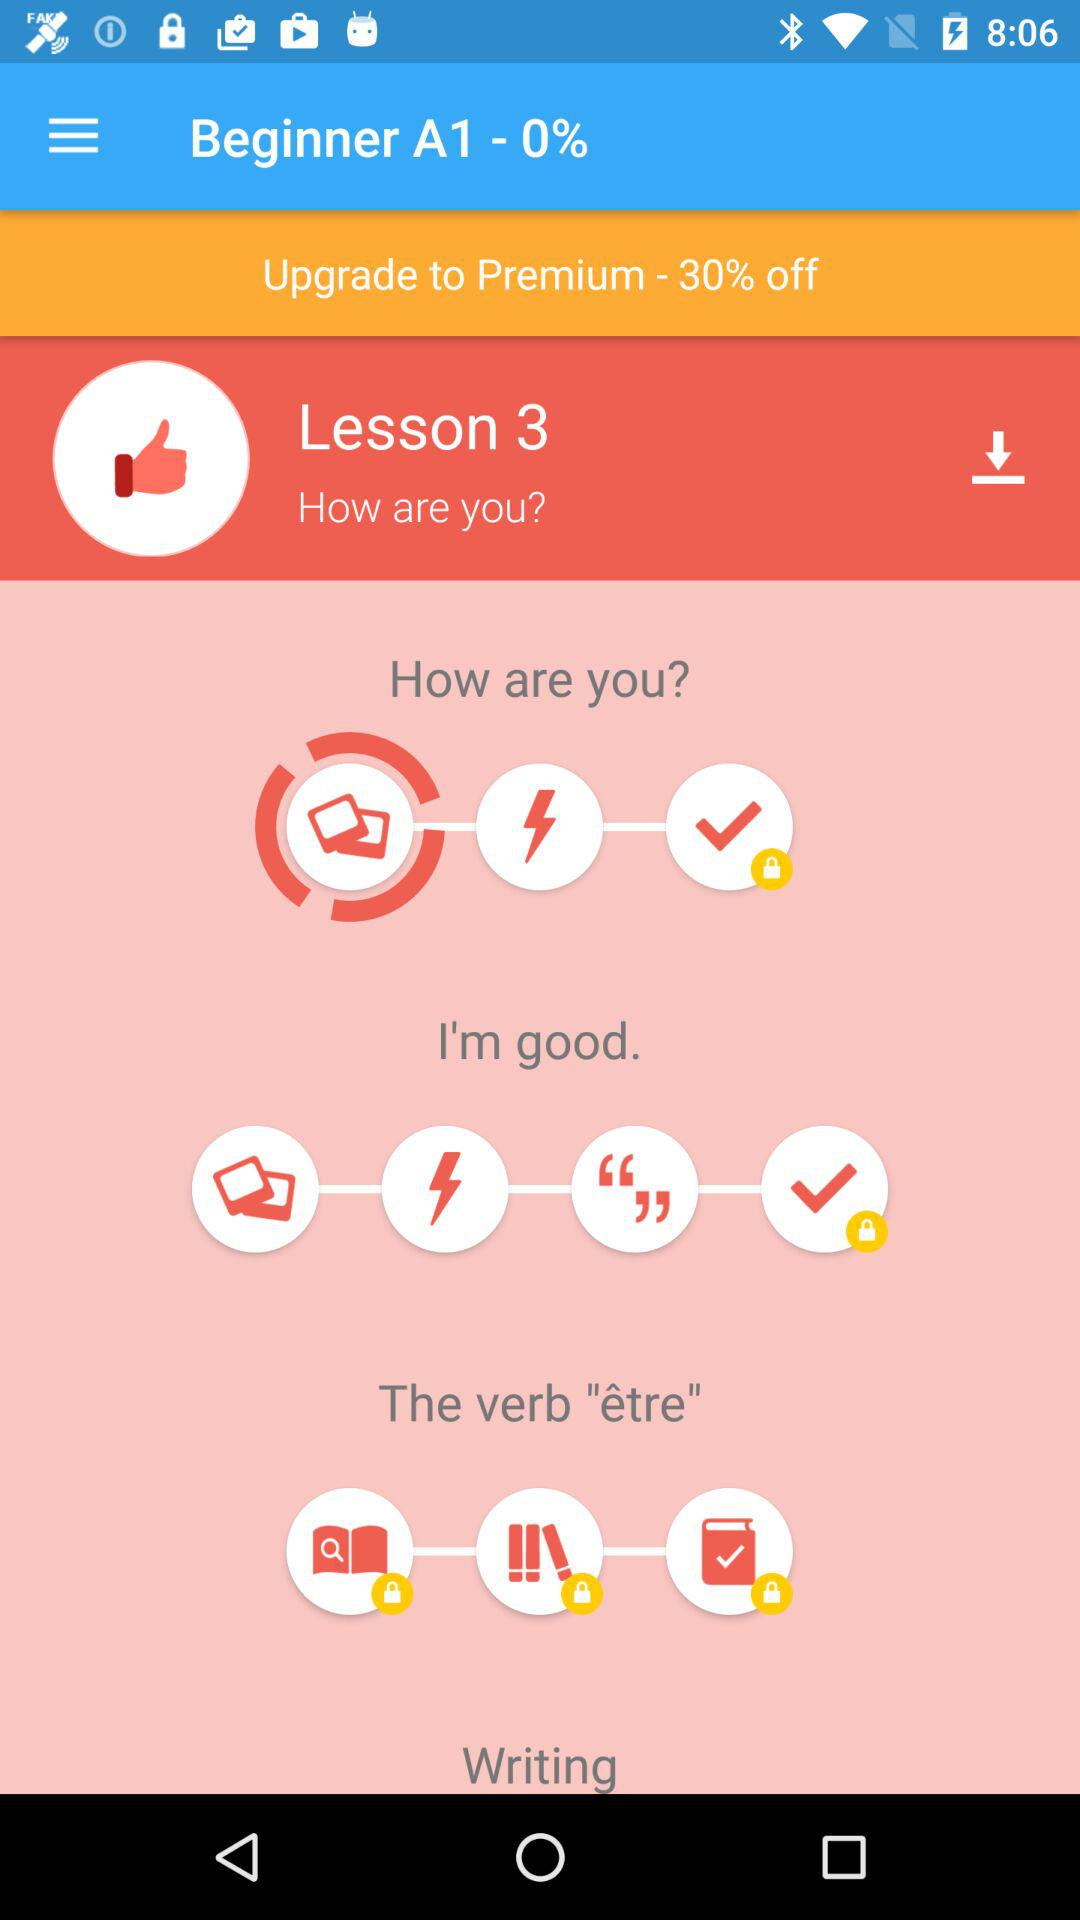Could you guide me through starting Lesson 3? To start Lesson 3, which is titled 'How are you?', you'll need to first select the lesson on the app. You'll begin with the introduction to the question 'How are you?', which includes auditory and pronunciation practice. Following this, proceed through interactive activities such as matching phrases, writing exercises, and speaking practice, all geared towards helping you understand and use the phrase 'How are you?' and the appropriate responses in conversational French. 